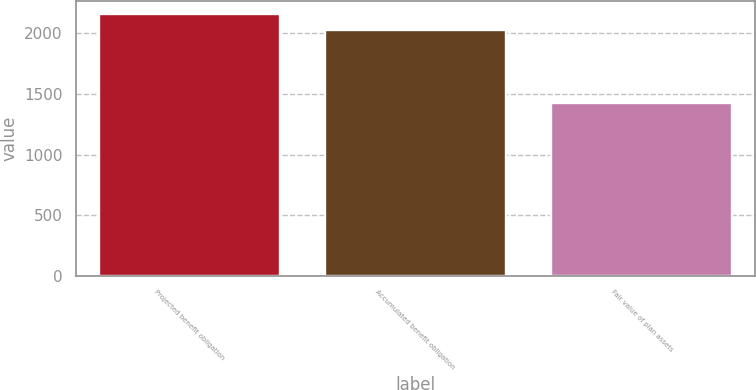Convert chart. <chart><loc_0><loc_0><loc_500><loc_500><bar_chart><fcel>Projected benefit obligation<fcel>Accumulated benefit obligation<fcel>Fair value of plan assets<nl><fcel>2158.4<fcel>2027.8<fcel>1429<nl></chart> 